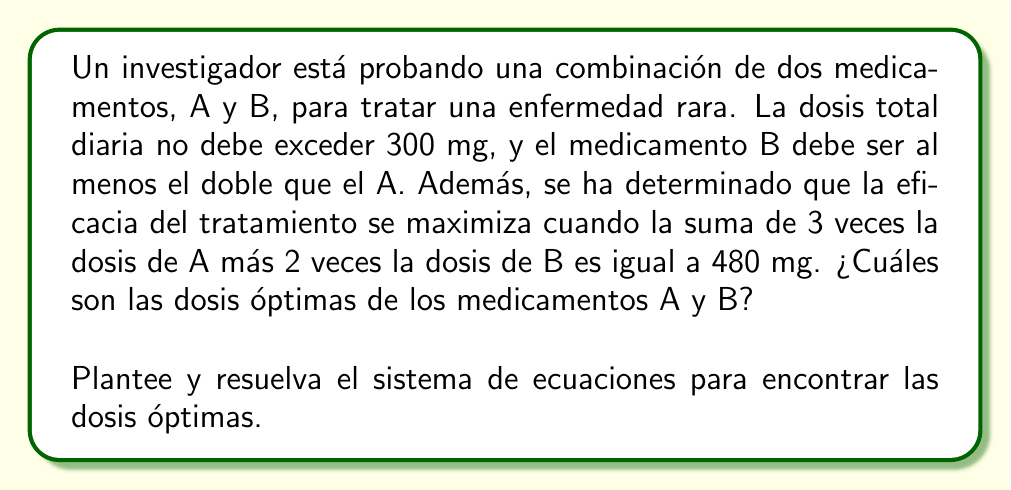Show me your answer to this math problem. Paso 1: Definir las variables
Sea $x$ la dosis del medicamento A en mg
Sea $y$ la dosis del medicamento B en mg

Paso 2: Plantear el sistema de ecuaciones
1) La dosis total no debe exceder 300 mg:
   $$x + y \leq 300$$

2) El medicamento B debe ser al menos el doble que el A:
   $$y \geq 2x$$

3) La eficacia se maximiza cuando:
   $$3x + 2y = 480$$

4) Además, sabemos que las dosis deben ser no negativas:
   $$x \geq 0, y \geq 0$$

Paso 3: Resolver el sistema de ecuaciones
Usaremos la ecuación 3 y la desigualdad 2 para encontrar la solución:

De la ecuación 3:
$$3x + 2y = 480$$

Despejamos y:
$$y = 240 - \frac{3x}{2}$$

Sustituyendo en la desigualdad 2:
$$240 - \frac{3x}{2} \geq 2x$$
$$240 \geq \frac{7x}{2}$$
$$\frac{480}{7} \geq x$$

Por lo tanto, el valor máximo de x es:
$$x = \frac{480}{7} \approx 68.57$$

Sustituyendo este valor en la ecuación para y:
$$y = 240 - \frac{3(480/7)}{2} = 240 - \frac{720}{7} \approx 137.14$$

Paso 4: Verificar las restricciones
- Dosis total: $68.57 + 137.14 = 205.71 \leq 300$ (cumple)
- B al menos el doble de A: $137.14 \geq 2(68.57)$ (cumple)
- Eficacia máxima: $3(68.57) + 2(137.14) = 480$ (cumple)
- Dosis no negativas: ambas son positivas (cumple)

Paso 5: Redondear a dosis prácticas
Redondeamos a números enteros para obtener dosis prácticas:
$x = 69$ mg (medicamento A)
$y = 137$ mg (medicamento B)
Answer: Medicamento A: 69 mg, Medicamento B: 137 mg 